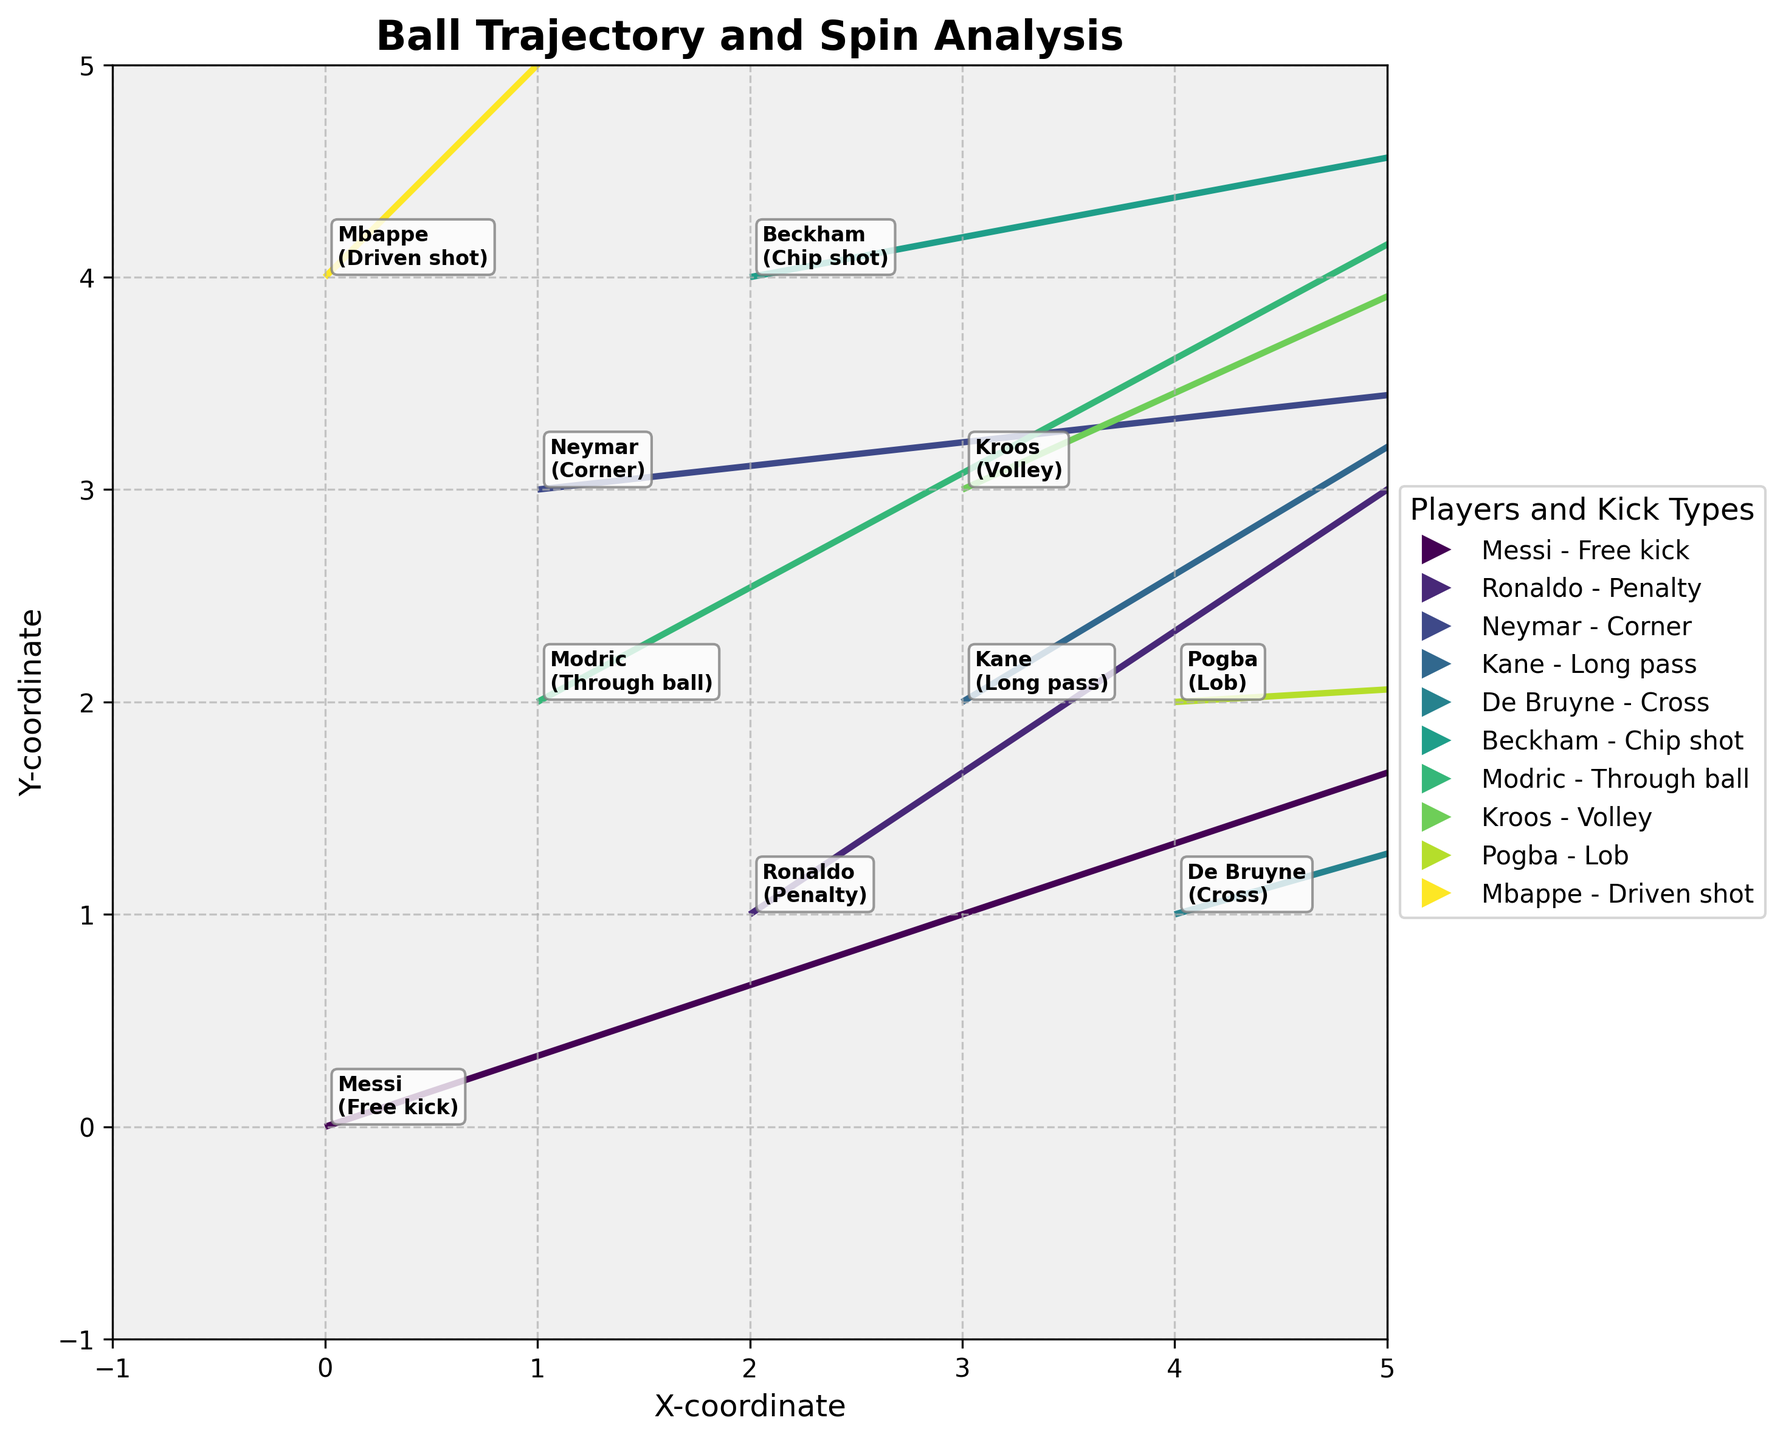Which player has the highest x-coordinate starting point? By looking at the x-coordinates, De Bruyne starts at x=4, the highest among all players.
Answer: De Bruyne What is the player and kick type associated with the vector that has the highest y-coordinate starting point? Checking the starting y-coordinates, Mbappe starts at y=4, which is the highest.
Answer: Mbappe - Driven shot How many different types of kicks are represented in the plot? By counting the unique values in the 'kick_type' column, we find Free kick, Penalty, Corner, Long pass, Cross, Chip shot, Through ball, Volley, Lob, and Driven shot.
Answer: 10 Which player has the vector pointing furthest to the right along the x-axis? By assessing the horizontal components (u), Pogba's vector (u=17) extends furthest in the positive x-direction.
Answer: Pogba Which player's trajectory has the steepest angle compared to the positive x-axis? A steeper angle means a higher v/u ratio. Mbappe's vector has the steepest angle with u=9 and v=9, giving the steepest slope v/u = 1.
Answer: Mbappe Which player has the slowest vector movement (smallest magnitude)? The vector magnitude is given by sqrt(u^2 + v^2). Calculating this for each vector, Kroos has the smallest, sqrt(11^2 + 5^2) = sqrt(146) ≈ 12.1.
Answer: Kroos Compare the trajectory vectors of Ronaldo and Neymar. Which one is longer? Calculate the vector length: for Ronaldo sqrt(12^2 + 8^2) ≈ 14.4; for Neymar sqrt(18^2 + 2^2) ≈ 18.1. Neymar's vector is longer.
Answer: Neymar Who has a trajectory closest to the origin with a horizontal component of 15? Messi's vector starts at (0,0) and has a horizontal component u of 15.
Answer: Messi Assess the direction of Modric's trajectory. Is it vertical, horizontal, or diagonal? Modric's trajectory vector has both u and v components (u=13, v=7), indicating a diagonal direction.
Answer: Diagonal 